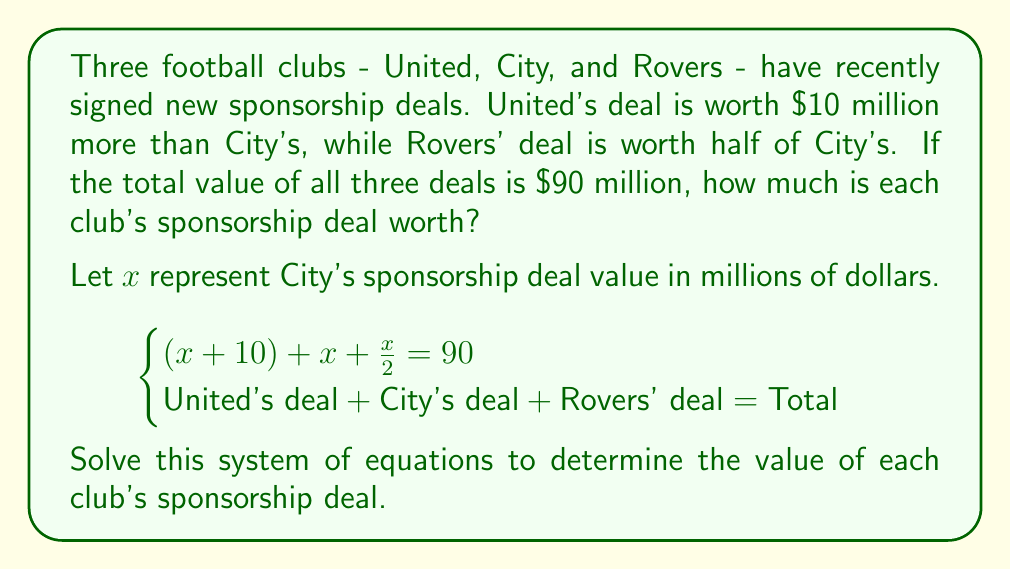Can you answer this question? Let's solve this step-by-step:

1) We start with the equation:
   $$(x + 10) + x + \frac{x}{2} = 90$$

2) Simplify the left side of the equation:
   $$x + 10 + x + \frac{x}{2} = 90$$
   $$2x + 10 + \frac{x}{2} = 90$$

3) To eliminate fractions, multiply both sides by 2:
   $$2(2x + 10 + \frac{x}{2}) = 2(90)$$
   $$4x + 20 + x = 180$$

4) Simplify:
   $$5x + 20 = 180$$

5) Subtract 20 from both sides:
   $$5x = 160$$

6) Divide both sides by 5:
   $$x = 32$$

7) Now that we know City's deal ($x$) is worth $32 million, we can calculate the others:
   - United's deal: $x + 10 = 32 + 10 = 42$ million
   - Rovers' deal: $\frac{x}{2} = \frac{32}{2} = 16$ million

8) Verify the total:
   $$42 + 32 + 16 = 90$$ million, which matches the given total.
Answer: United's sponsorship deal: $42 million
City's sponsorship deal: $32 million
Rovers' sponsorship deal: $16 million 